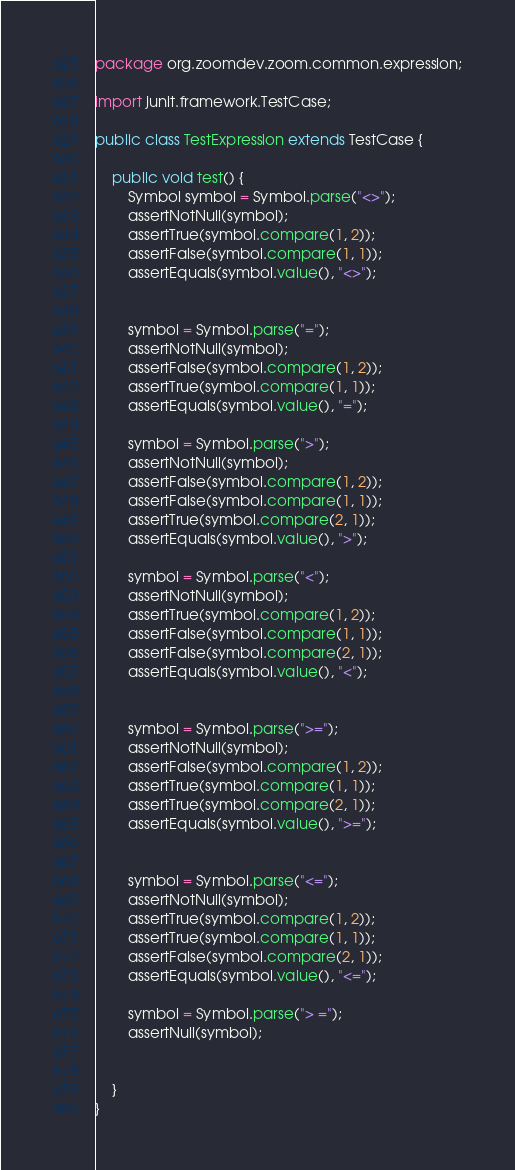<code> <loc_0><loc_0><loc_500><loc_500><_Java_>package org.zoomdev.zoom.common.expression;

import junit.framework.TestCase;

public class TestExpression extends TestCase {

    public void test() {
        Symbol symbol = Symbol.parse("<>");
        assertNotNull(symbol);
        assertTrue(symbol.compare(1, 2));
        assertFalse(symbol.compare(1, 1));
        assertEquals(symbol.value(), "<>");


        symbol = Symbol.parse("=");
        assertNotNull(symbol);
        assertFalse(symbol.compare(1, 2));
        assertTrue(symbol.compare(1, 1));
        assertEquals(symbol.value(), "=");

        symbol = Symbol.parse(">");
        assertNotNull(symbol);
        assertFalse(symbol.compare(1, 2));
        assertFalse(symbol.compare(1, 1));
        assertTrue(symbol.compare(2, 1));
        assertEquals(symbol.value(), ">");

        symbol = Symbol.parse("<");
        assertNotNull(symbol);
        assertTrue(symbol.compare(1, 2));
        assertFalse(symbol.compare(1, 1));
        assertFalse(symbol.compare(2, 1));
        assertEquals(symbol.value(), "<");


        symbol = Symbol.parse(">=");
        assertNotNull(symbol);
        assertFalse(symbol.compare(1, 2));
        assertTrue(symbol.compare(1, 1));
        assertTrue(symbol.compare(2, 1));
        assertEquals(symbol.value(), ">=");


        symbol = Symbol.parse("<=");
        assertNotNull(symbol);
        assertTrue(symbol.compare(1, 2));
        assertTrue(symbol.compare(1, 1));
        assertFalse(symbol.compare(2, 1));
        assertEquals(symbol.value(), "<=");

        symbol = Symbol.parse("> =");
        assertNull(symbol);


    }
}
</code> 